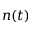Convert formula to latex. <formula><loc_0><loc_0><loc_500><loc_500>n ( t )</formula> 